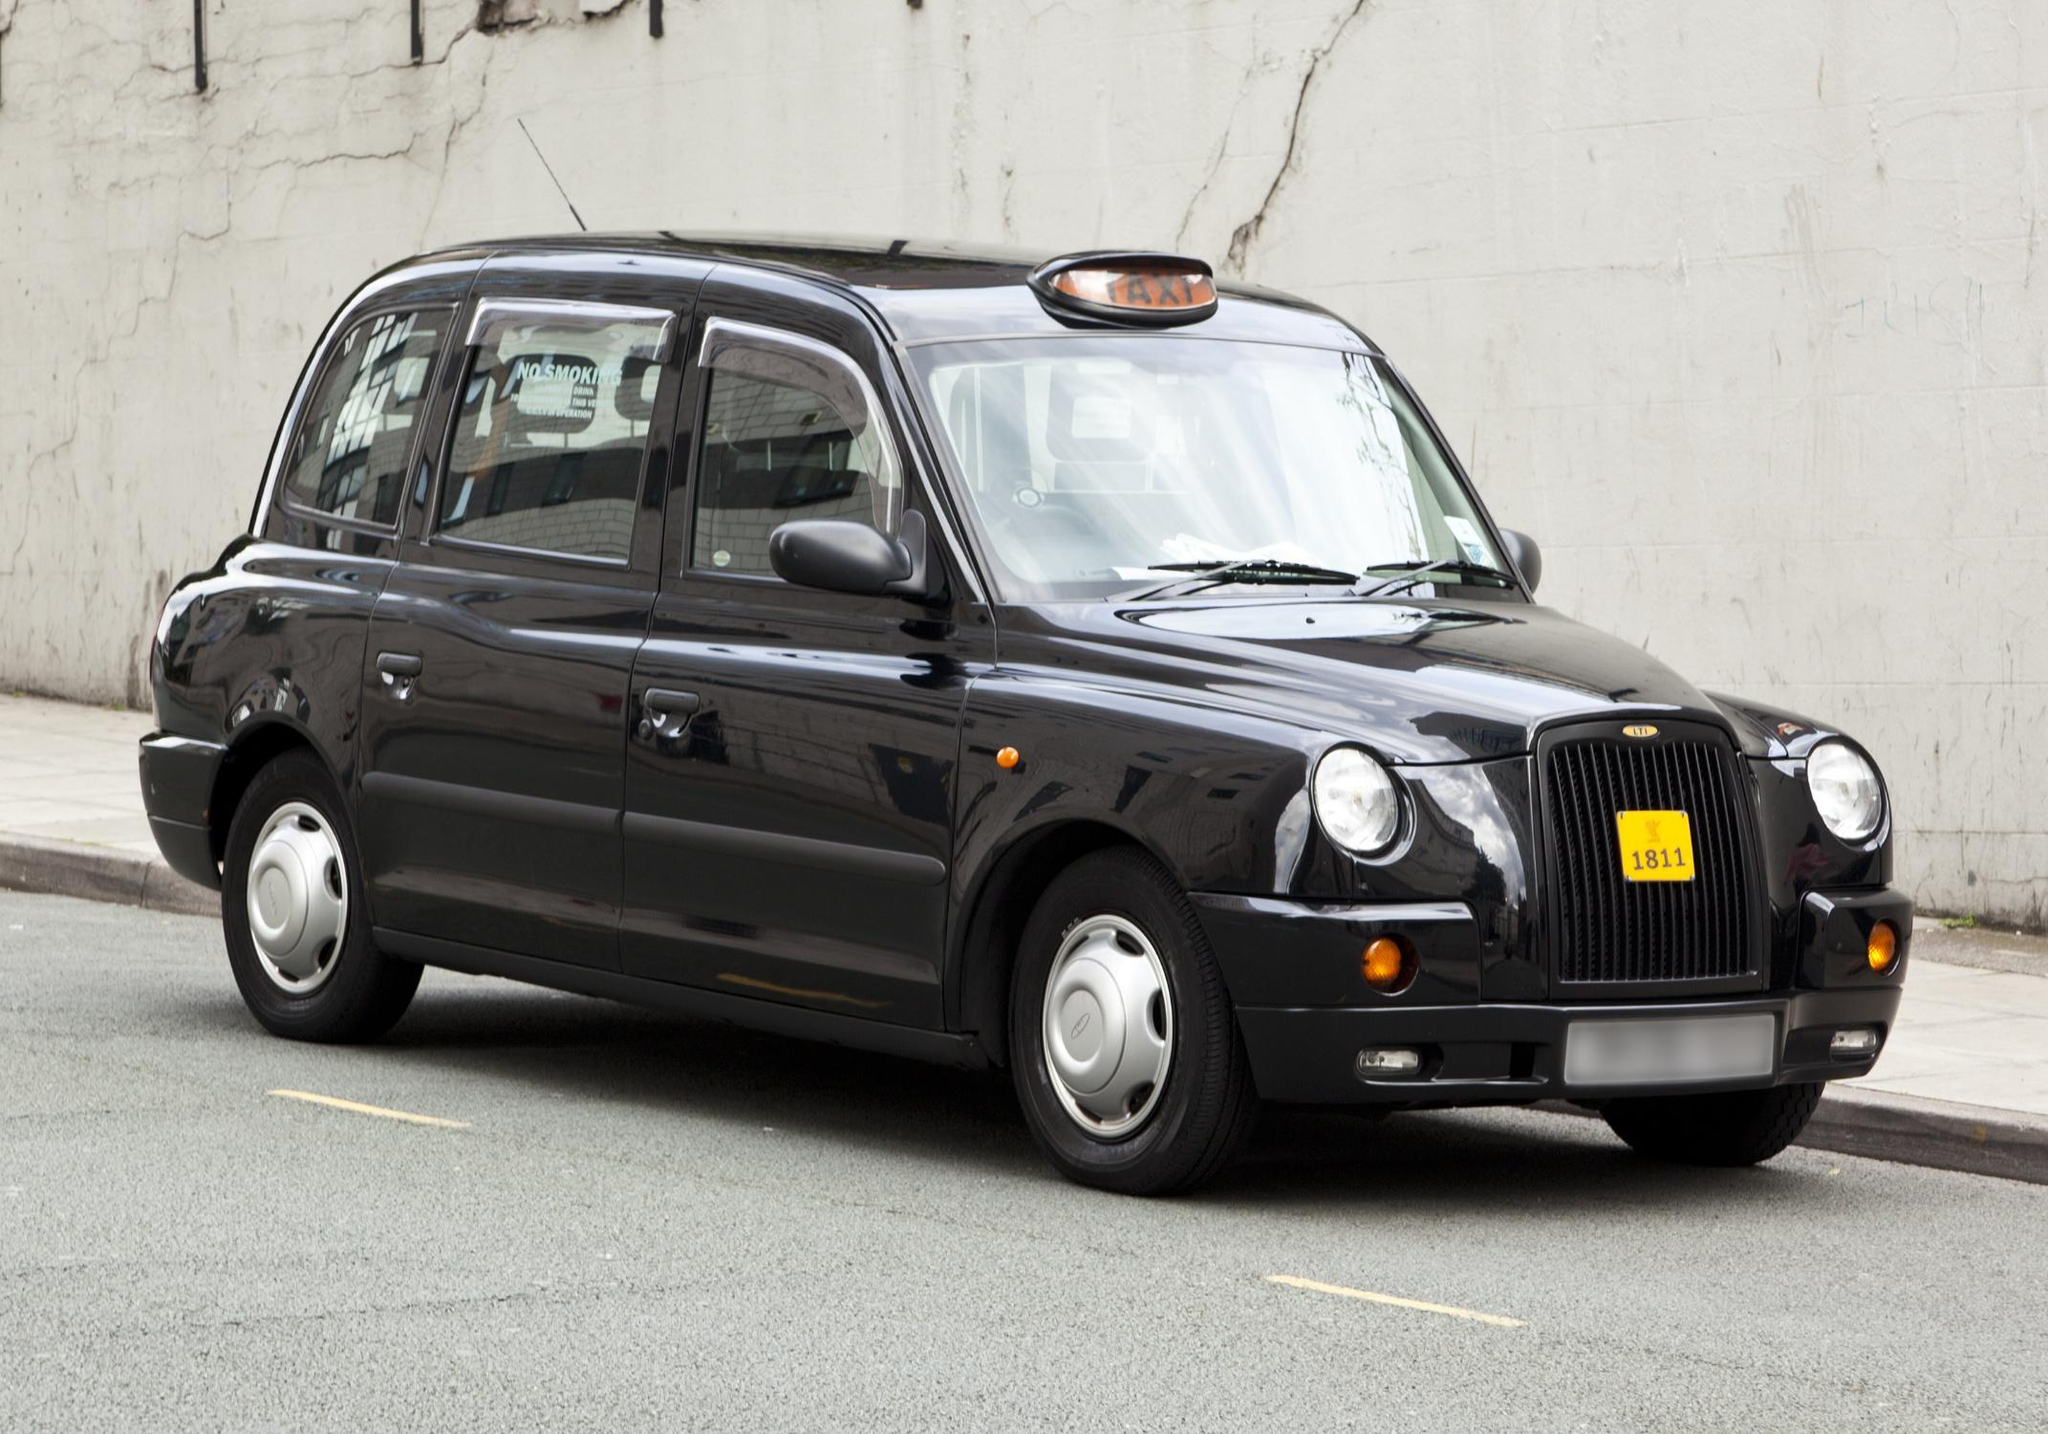Explore the history and cultural significance of the London taxi. London's taxis, often referred to as 'Black Cabs', are an enduring symbol of the city, recognized worldwide. Their history dates back to the 17th century with horse-drawn carriages. The iconic black cab design, especially this TX series, has been around since the mid-20th century, designed to meet specific regulations that define a 'Hackney carriage'. They're known for their high standards of maintenance and the rigorous examination known as 'The Knowledge', which drivers must pass to operate. These taxis not only serve as reliable transportation but also embody a rich history of London's urban evolution and are a cherished part of the city's cultural fabric. 